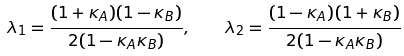Convert formula to latex. <formula><loc_0><loc_0><loc_500><loc_500>\lambda _ { 1 } = \frac { ( 1 + \kappa _ { A } ) ( 1 - \kappa _ { B } ) } { 2 ( 1 - \kappa _ { A } \kappa _ { B } ) } , \quad \lambda _ { 2 } = \frac { ( 1 - \kappa _ { A } ) ( 1 + \kappa _ { B } ) } { 2 ( 1 - \kappa _ { A } \kappa _ { B } ) }</formula> 